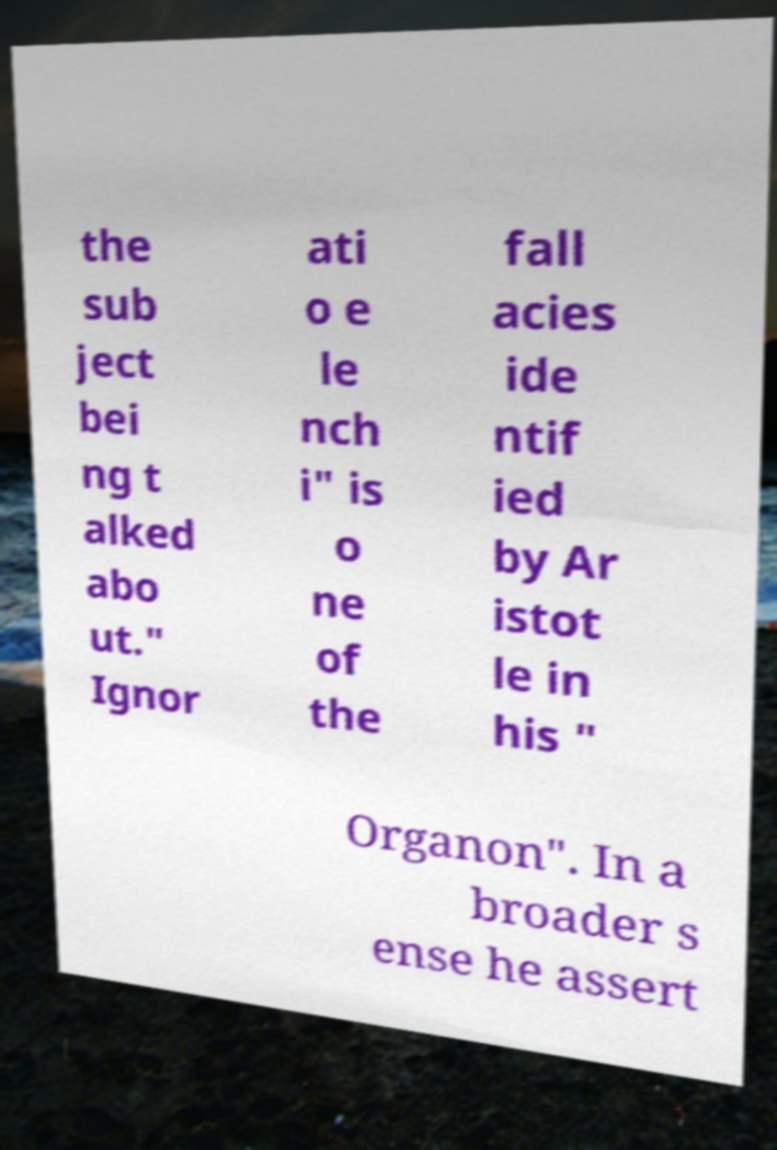There's text embedded in this image that I need extracted. Can you transcribe it verbatim? the sub ject bei ng t alked abo ut." Ignor ati o e le nch i" is o ne of the fall acies ide ntif ied by Ar istot le in his " Organon". In a broader s ense he assert 